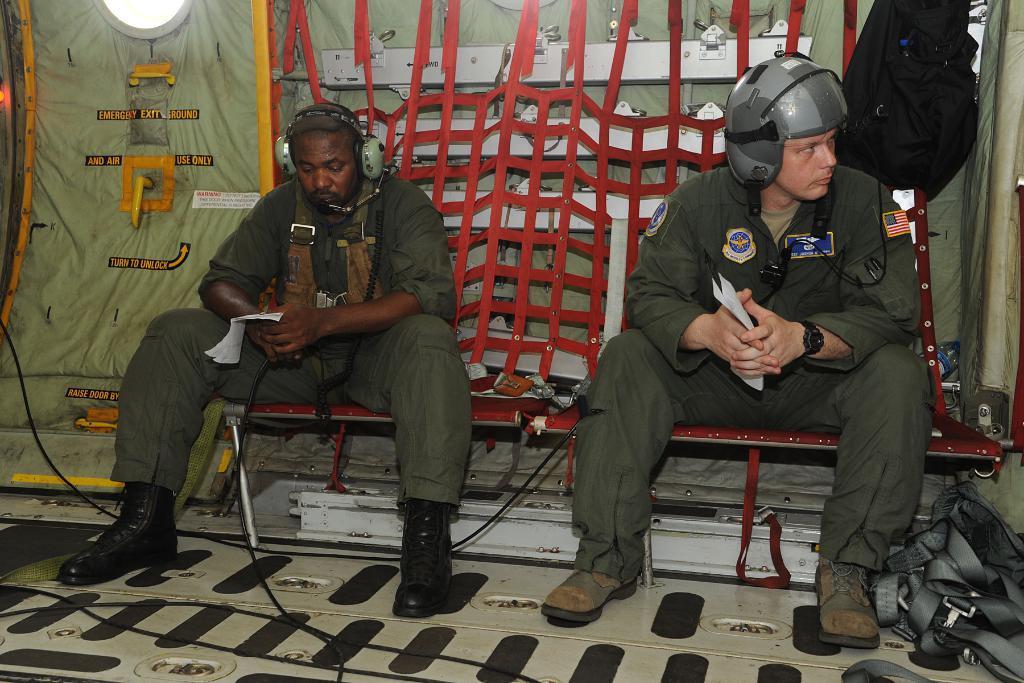Can you describe this image briefly? The image might be taken inside an airplane. In the center of the picture there is a bench, on the bench there are two soldiers sitting. In the background there are nets, gate and some other objects. In the foreground we can see cables. On the right there is a bag like object. 